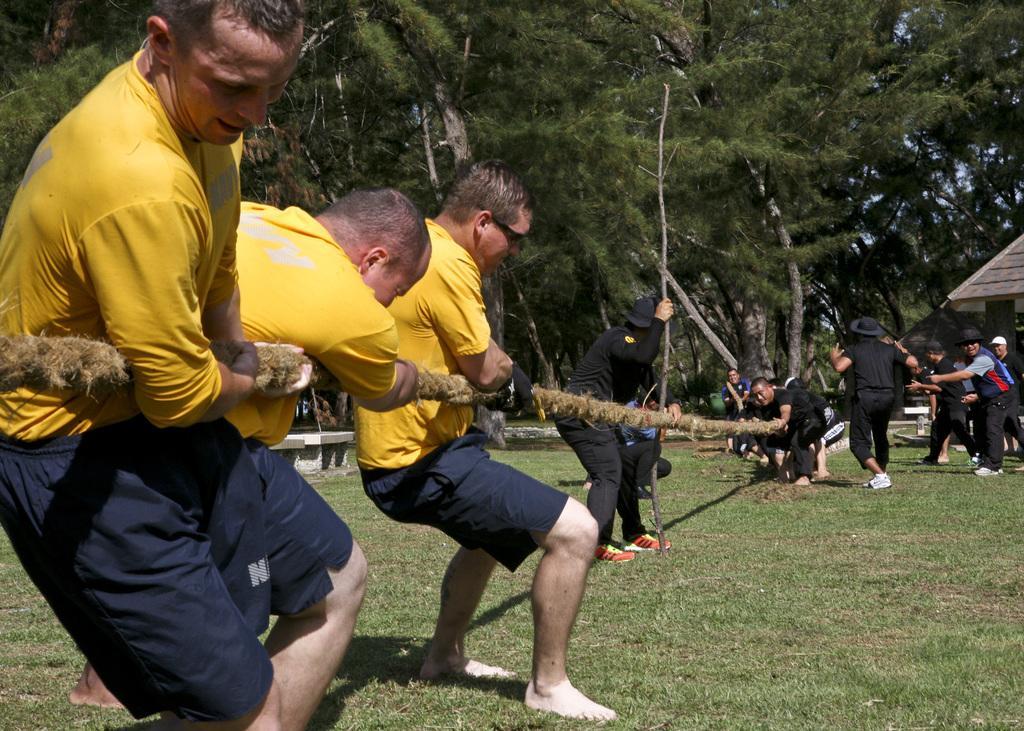Could you give a brief overview of what you see in this image? In this image, we can see persons wearing clothes. There are some persons holding a rope with their hands. There is person in the middle of the image holding a stick with his hand. There are some trees at the top of the image. There is a grass on the ground. 